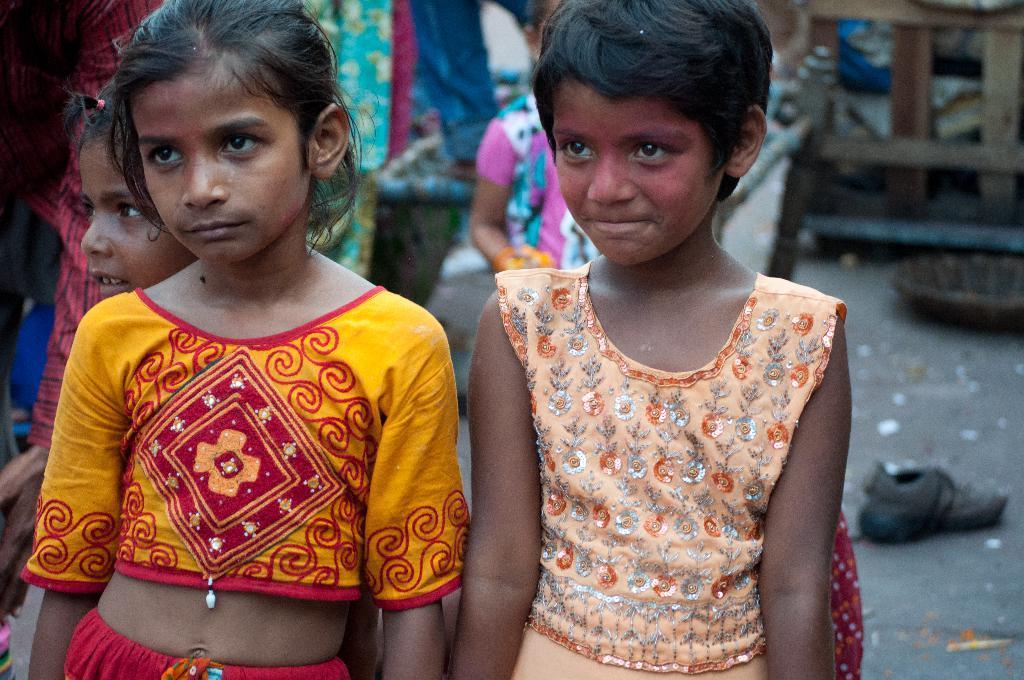Describe this image in one or two sentences. Front we can see three girls. Background it is blurry and we can see people, shoe and basket. 